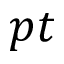<formula> <loc_0><loc_0><loc_500><loc_500>p t</formula> 